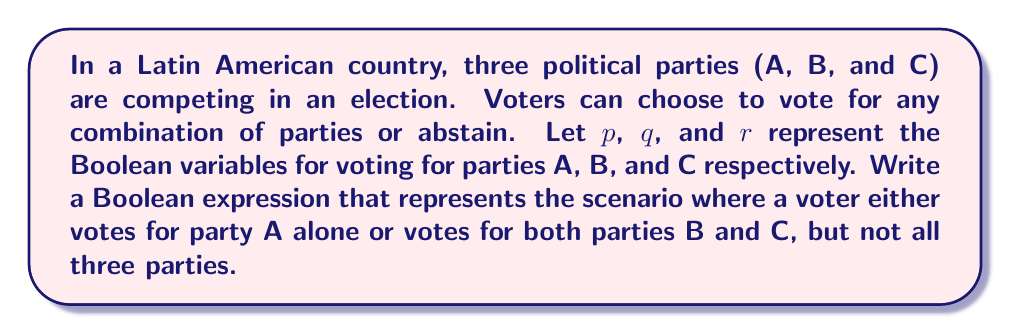Can you solve this math problem? To solve this problem, we need to construct a Boolean expression that captures the given conditions. Let's break it down step-by-step:

1. Voting for party A alone can be expressed as: $p \wedge \neg q \wedge \neg r$

2. Voting for both parties B and C (but not A) can be expressed as: $\neg p \wedge q \wedge r$

3. We want either of these conditions to be true, so we use the OR operator ($\vee$) to combine them:

   $$(p \wedge \neg q \wedge \neg r) \vee (\neg p \wedge q \wedge r)$$

4. This expression already excludes the case of voting for all three parties, so no additional terms are needed.

5. The final Boolean expression that represents the desired voting pattern is:

   $$(p \wedge \neg q \wedge \neg r) \vee (\neg p \wedge q \wedge r)$$

This expression will evaluate to true if and only if a voter either votes for party A alone or votes for both parties B and C, but not all three parties.
Answer: $(p \wedge \neg q \wedge \neg r) \vee (\neg p \wedge q \wedge r)$ 